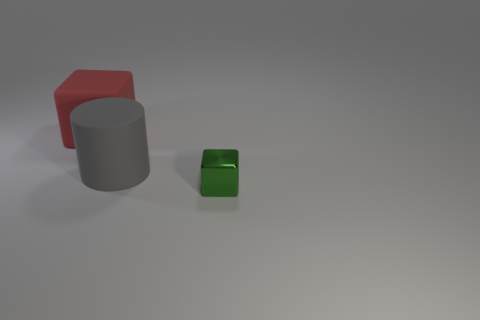Subtract 1 cylinders. How many cylinders are left? 0 Add 2 large purple matte cylinders. How many objects exist? 5 Subtract all green blocks. How many blocks are left? 1 Subtract all cubes. How many objects are left? 1 Add 3 large red rubber things. How many large red rubber things are left? 4 Add 1 large gray cylinders. How many large gray cylinders exist? 2 Subtract 0 blue cubes. How many objects are left? 3 Subtract all green blocks. Subtract all red balls. How many blocks are left? 1 Subtract all blue cylinders. How many brown cubes are left? 0 Subtract all large gray matte cylinders. Subtract all large cylinders. How many objects are left? 1 